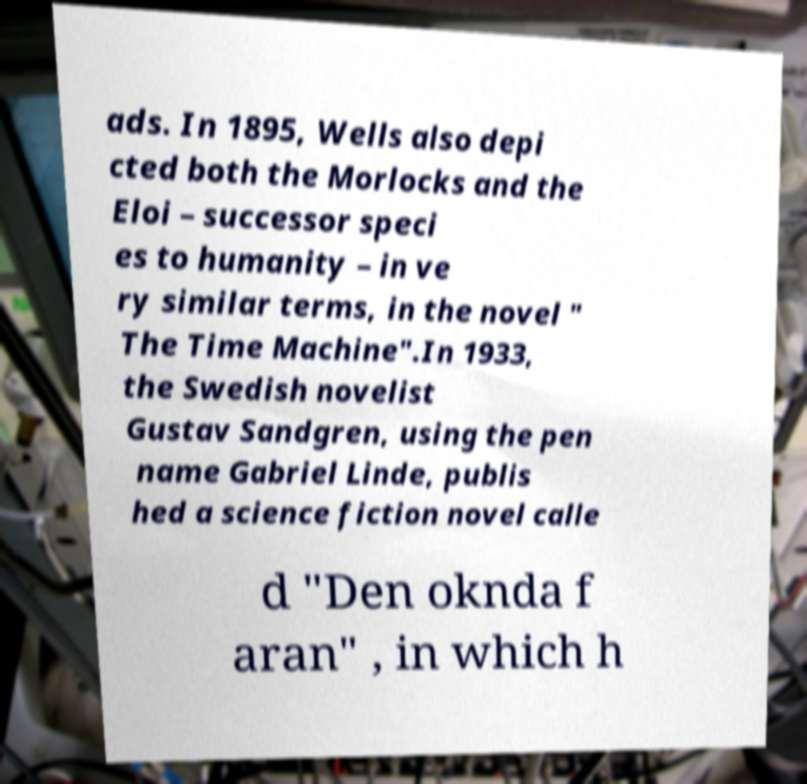What messages or text are displayed in this image? I need them in a readable, typed format. ads. In 1895, Wells also depi cted both the Morlocks and the Eloi – successor speci es to humanity – in ve ry similar terms, in the novel " The Time Machine".In 1933, the Swedish novelist Gustav Sandgren, using the pen name Gabriel Linde, publis hed a science fiction novel calle d "Den oknda f aran" , in which h 